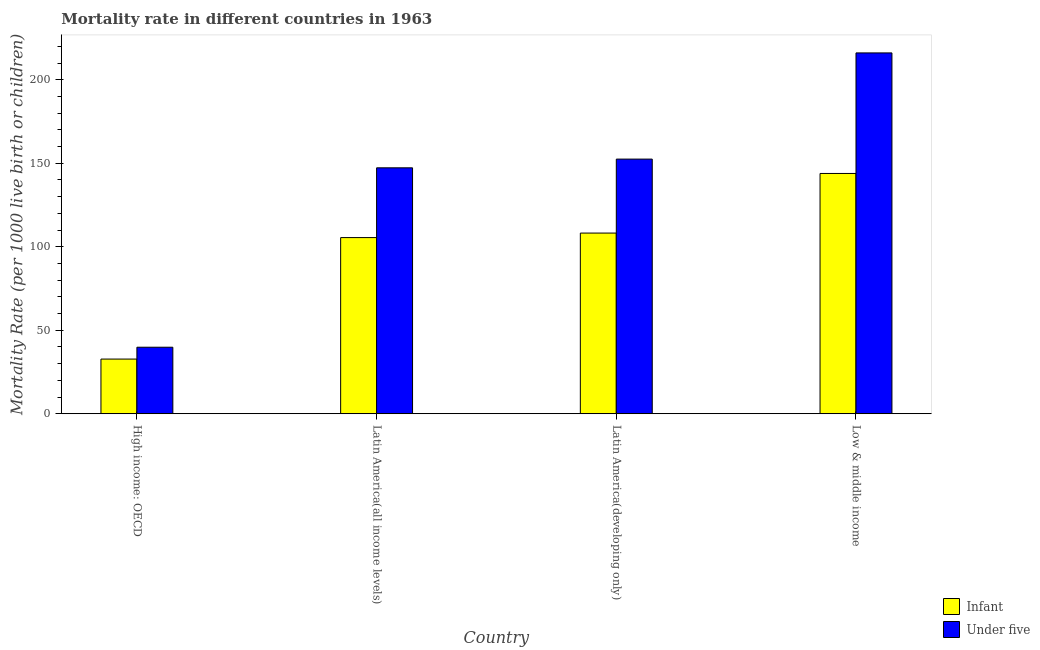How many bars are there on the 1st tick from the right?
Give a very brief answer. 2. What is the label of the 1st group of bars from the left?
Keep it short and to the point. High income: OECD. What is the infant mortality rate in Latin America(all income levels)?
Offer a very short reply. 105.5. Across all countries, what is the maximum infant mortality rate?
Ensure brevity in your answer.  143.9. Across all countries, what is the minimum infant mortality rate?
Offer a terse response. 32.74. In which country was the under-5 mortality rate maximum?
Keep it short and to the point. Low & middle income. In which country was the infant mortality rate minimum?
Offer a terse response. High income: OECD. What is the total infant mortality rate in the graph?
Give a very brief answer. 390.33. What is the difference between the under-5 mortality rate in High income: OECD and that in Low & middle income?
Offer a terse response. -176.27. What is the difference between the under-5 mortality rate in Latin America(all income levels) and the infant mortality rate in Low & middle income?
Provide a succinct answer. 3.38. What is the average under-5 mortality rate per country?
Provide a succinct answer. 138.93. What is the difference between the under-5 mortality rate and infant mortality rate in Latin America(all income levels)?
Offer a terse response. 41.78. What is the ratio of the infant mortality rate in Latin America(all income levels) to that in Latin America(developing only)?
Make the answer very short. 0.98. Is the under-5 mortality rate in Latin America(all income levels) less than that in Latin America(developing only)?
Offer a very short reply. Yes. What is the difference between the highest and the second highest under-5 mortality rate?
Your answer should be very brief. 63.6. What is the difference between the highest and the lowest infant mortality rate?
Provide a short and direct response. 111.16. Is the sum of the infant mortality rate in High income: OECD and Low & middle income greater than the maximum under-5 mortality rate across all countries?
Provide a succinct answer. No. What does the 1st bar from the left in Low & middle income represents?
Make the answer very short. Infant. What does the 1st bar from the right in High income: OECD represents?
Your response must be concise. Under five. How many bars are there?
Offer a very short reply. 8. Are all the bars in the graph horizontal?
Offer a terse response. No. Are the values on the major ticks of Y-axis written in scientific E-notation?
Provide a succinct answer. No. Does the graph contain any zero values?
Your answer should be compact. No. Does the graph contain grids?
Give a very brief answer. No. How are the legend labels stacked?
Provide a short and direct response. Vertical. What is the title of the graph?
Provide a short and direct response. Mortality rate in different countries in 1963. What is the label or title of the X-axis?
Offer a terse response. Country. What is the label or title of the Y-axis?
Your answer should be compact. Mortality Rate (per 1000 live birth or children). What is the Mortality Rate (per 1000 live birth or children) in Infant in High income: OECD?
Your answer should be very brief. 32.74. What is the Mortality Rate (per 1000 live birth or children) in Under five in High income: OECD?
Give a very brief answer. 39.83. What is the Mortality Rate (per 1000 live birth or children) of Infant in Latin America(all income levels)?
Provide a short and direct response. 105.5. What is the Mortality Rate (per 1000 live birth or children) in Under five in Latin America(all income levels)?
Make the answer very short. 147.28. What is the Mortality Rate (per 1000 live birth or children) of Infant in Latin America(developing only)?
Your answer should be very brief. 108.2. What is the Mortality Rate (per 1000 live birth or children) in Under five in Latin America(developing only)?
Provide a short and direct response. 152.5. What is the Mortality Rate (per 1000 live birth or children) of Infant in Low & middle income?
Your answer should be very brief. 143.9. What is the Mortality Rate (per 1000 live birth or children) of Under five in Low & middle income?
Offer a very short reply. 216.1. Across all countries, what is the maximum Mortality Rate (per 1000 live birth or children) of Infant?
Offer a very short reply. 143.9. Across all countries, what is the maximum Mortality Rate (per 1000 live birth or children) in Under five?
Provide a short and direct response. 216.1. Across all countries, what is the minimum Mortality Rate (per 1000 live birth or children) in Infant?
Provide a short and direct response. 32.74. Across all countries, what is the minimum Mortality Rate (per 1000 live birth or children) in Under five?
Offer a terse response. 39.83. What is the total Mortality Rate (per 1000 live birth or children) of Infant in the graph?
Offer a terse response. 390.33. What is the total Mortality Rate (per 1000 live birth or children) in Under five in the graph?
Your answer should be compact. 555.71. What is the difference between the Mortality Rate (per 1000 live birth or children) in Infant in High income: OECD and that in Latin America(all income levels)?
Your answer should be compact. -72.76. What is the difference between the Mortality Rate (per 1000 live birth or children) of Under five in High income: OECD and that in Latin America(all income levels)?
Offer a very short reply. -107.45. What is the difference between the Mortality Rate (per 1000 live birth or children) in Infant in High income: OECD and that in Latin America(developing only)?
Give a very brief answer. -75.46. What is the difference between the Mortality Rate (per 1000 live birth or children) in Under five in High income: OECD and that in Latin America(developing only)?
Offer a terse response. -112.67. What is the difference between the Mortality Rate (per 1000 live birth or children) of Infant in High income: OECD and that in Low & middle income?
Offer a terse response. -111.16. What is the difference between the Mortality Rate (per 1000 live birth or children) of Under five in High income: OECD and that in Low & middle income?
Keep it short and to the point. -176.27. What is the difference between the Mortality Rate (per 1000 live birth or children) in Infant in Latin America(all income levels) and that in Latin America(developing only)?
Give a very brief answer. -2.71. What is the difference between the Mortality Rate (per 1000 live birth or children) of Under five in Latin America(all income levels) and that in Latin America(developing only)?
Provide a succinct answer. -5.22. What is the difference between the Mortality Rate (per 1000 live birth or children) in Infant in Latin America(all income levels) and that in Low & middle income?
Provide a succinct answer. -38.41. What is the difference between the Mortality Rate (per 1000 live birth or children) in Under five in Latin America(all income levels) and that in Low & middle income?
Your answer should be compact. -68.82. What is the difference between the Mortality Rate (per 1000 live birth or children) in Infant in Latin America(developing only) and that in Low & middle income?
Your answer should be very brief. -35.7. What is the difference between the Mortality Rate (per 1000 live birth or children) in Under five in Latin America(developing only) and that in Low & middle income?
Keep it short and to the point. -63.6. What is the difference between the Mortality Rate (per 1000 live birth or children) of Infant in High income: OECD and the Mortality Rate (per 1000 live birth or children) of Under five in Latin America(all income levels)?
Make the answer very short. -114.54. What is the difference between the Mortality Rate (per 1000 live birth or children) of Infant in High income: OECD and the Mortality Rate (per 1000 live birth or children) of Under five in Latin America(developing only)?
Provide a short and direct response. -119.76. What is the difference between the Mortality Rate (per 1000 live birth or children) in Infant in High income: OECD and the Mortality Rate (per 1000 live birth or children) in Under five in Low & middle income?
Ensure brevity in your answer.  -183.36. What is the difference between the Mortality Rate (per 1000 live birth or children) in Infant in Latin America(all income levels) and the Mortality Rate (per 1000 live birth or children) in Under five in Latin America(developing only)?
Offer a very short reply. -47.01. What is the difference between the Mortality Rate (per 1000 live birth or children) of Infant in Latin America(all income levels) and the Mortality Rate (per 1000 live birth or children) of Under five in Low & middle income?
Your answer should be compact. -110.61. What is the difference between the Mortality Rate (per 1000 live birth or children) in Infant in Latin America(developing only) and the Mortality Rate (per 1000 live birth or children) in Under five in Low & middle income?
Offer a terse response. -107.9. What is the average Mortality Rate (per 1000 live birth or children) of Infant per country?
Offer a terse response. 97.58. What is the average Mortality Rate (per 1000 live birth or children) of Under five per country?
Your response must be concise. 138.93. What is the difference between the Mortality Rate (per 1000 live birth or children) in Infant and Mortality Rate (per 1000 live birth or children) in Under five in High income: OECD?
Give a very brief answer. -7.09. What is the difference between the Mortality Rate (per 1000 live birth or children) of Infant and Mortality Rate (per 1000 live birth or children) of Under five in Latin America(all income levels)?
Provide a succinct answer. -41.78. What is the difference between the Mortality Rate (per 1000 live birth or children) in Infant and Mortality Rate (per 1000 live birth or children) in Under five in Latin America(developing only)?
Ensure brevity in your answer.  -44.3. What is the difference between the Mortality Rate (per 1000 live birth or children) of Infant and Mortality Rate (per 1000 live birth or children) of Under five in Low & middle income?
Your answer should be compact. -72.2. What is the ratio of the Mortality Rate (per 1000 live birth or children) in Infant in High income: OECD to that in Latin America(all income levels)?
Keep it short and to the point. 0.31. What is the ratio of the Mortality Rate (per 1000 live birth or children) of Under five in High income: OECD to that in Latin America(all income levels)?
Provide a succinct answer. 0.27. What is the ratio of the Mortality Rate (per 1000 live birth or children) in Infant in High income: OECD to that in Latin America(developing only)?
Give a very brief answer. 0.3. What is the ratio of the Mortality Rate (per 1000 live birth or children) in Under five in High income: OECD to that in Latin America(developing only)?
Offer a very short reply. 0.26. What is the ratio of the Mortality Rate (per 1000 live birth or children) in Infant in High income: OECD to that in Low & middle income?
Your response must be concise. 0.23. What is the ratio of the Mortality Rate (per 1000 live birth or children) of Under five in High income: OECD to that in Low & middle income?
Provide a succinct answer. 0.18. What is the ratio of the Mortality Rate (per 1000 live birth or children) in Infant in Latin America(all income levels) to that in Latin America(developing only)?
Provide a short and direct response. 0.97. What is the ratio of the Mortality Rate (per 1000 live birth or children) of Under five in Latin America(all income levels) to that in Latin America(developing only)?
Your answer should be very brief. 0.97. What is the ratio of the Mortality Rate (per 1000 live birth or children) of Infant in Latin America(all income levels) to that in Low & middle income?
Keep it short and to the point. 0.73. What is the ratio of the Mortality Rate (per 1000 live birth or children) of Under five in Latin America(all income levels) to that in Low & middle income?
Your response must be concise. 0.68. What is the ratio of the Mortality Rate (per 1000 live birth or children) of Infant in Latin America(developing only) to that in Low & middle income?
Provide a short and direct response. 0.75. What is the ratio of the Mortality Rate (per 1000 live birth or children) in Under five in Latin America(developing only) to that in Low & middle income?
Provide a succinct answer. 0.71. What is the difference between the highest and the second highest Mortality Rate (per 1000 live birth or children) in Infant?
Provide a short and direct response. 35.7. What is the difference between the highest and the second highest Mortality Rate (per 1000 live birth or children) in Under five?
Your response must be concise. 63.6. What is the difference between the highest and the lowest Mortality Rate (per 1000 live birth or children) of Infant?
Your answer should be very brief. 111.16. What is the difference between the highest and the lowest Mortality Rate (per 1000 live birth or children) of Under five?
Give a very brief answer. 176.27. 